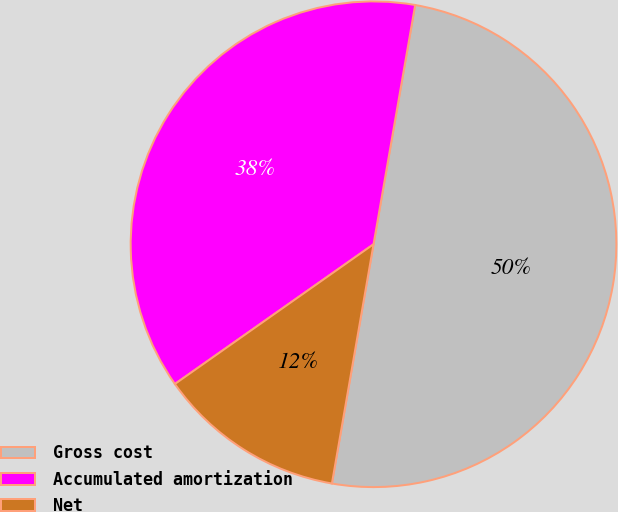Convert chart to OTSL. <chart><loc_0><loc_0><loc_500><loc_500><pie_chart><fcel>Gross cost<fcel>Accumulated amortization<fcel>Net<nl><fcel>50.0%<fcel>37.5%<fcel>12.5%<nl></chart> 